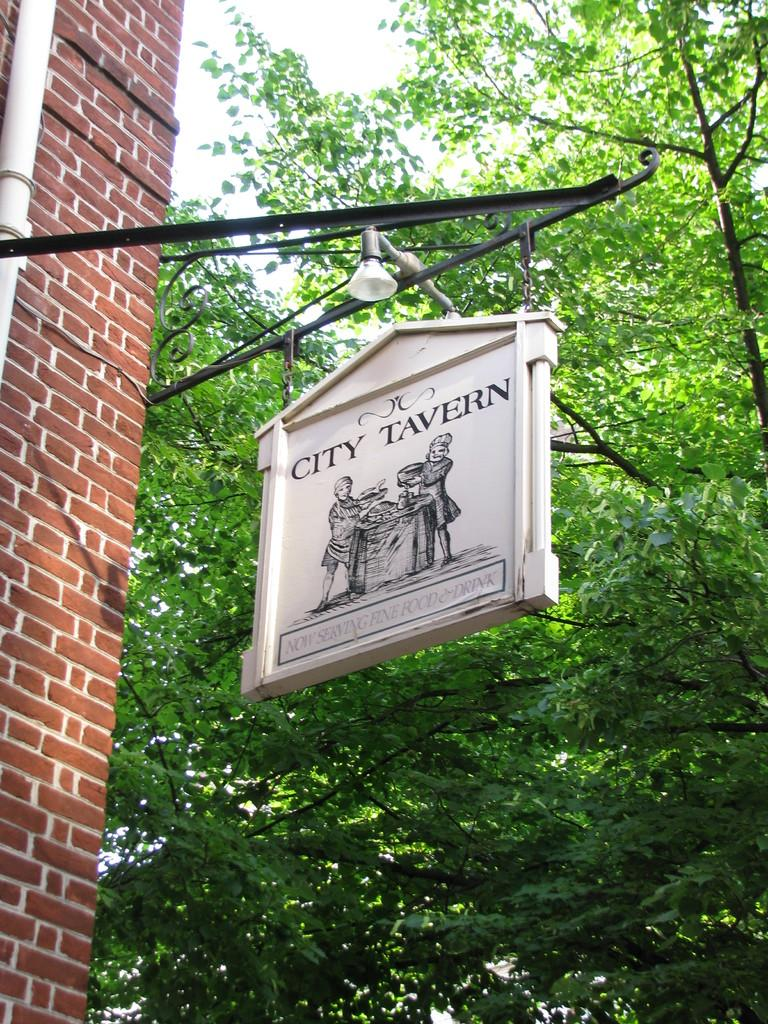What is hanging from an iron rod in the image? There is a sign board hanging from an iron rod in the image. What type of vegetation can be seen in the image? Trees are present in the image. What is the color and material of the wall in the image? There is a red brick wall in the image. How does the sign board get washed in the image? The sign board does not get washed in the image; it is a static object hanging from an iron rod. 